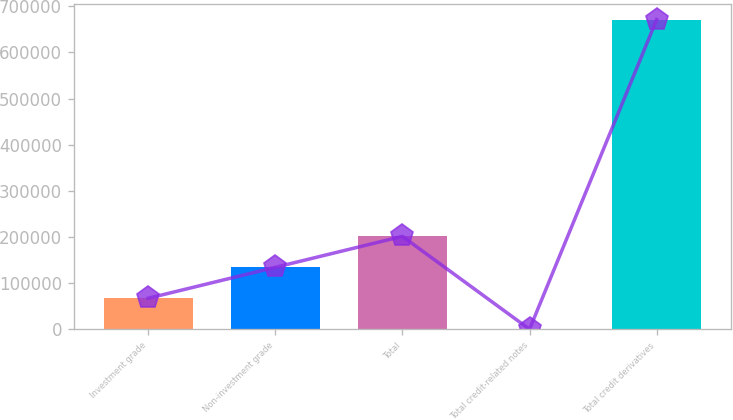<chart> <loc_0><loc_0><loc_500><loc_500><bar_chart><fcel>Investment grade<fcel>Non-investment grade<fcel>Total<fcel>Total credit-related notes<fcel>Total credit derivatives<nl><fcel>67252.5<fcel>134331<fcel>201410<fcel>174<fcel>670959<nl></chart> 